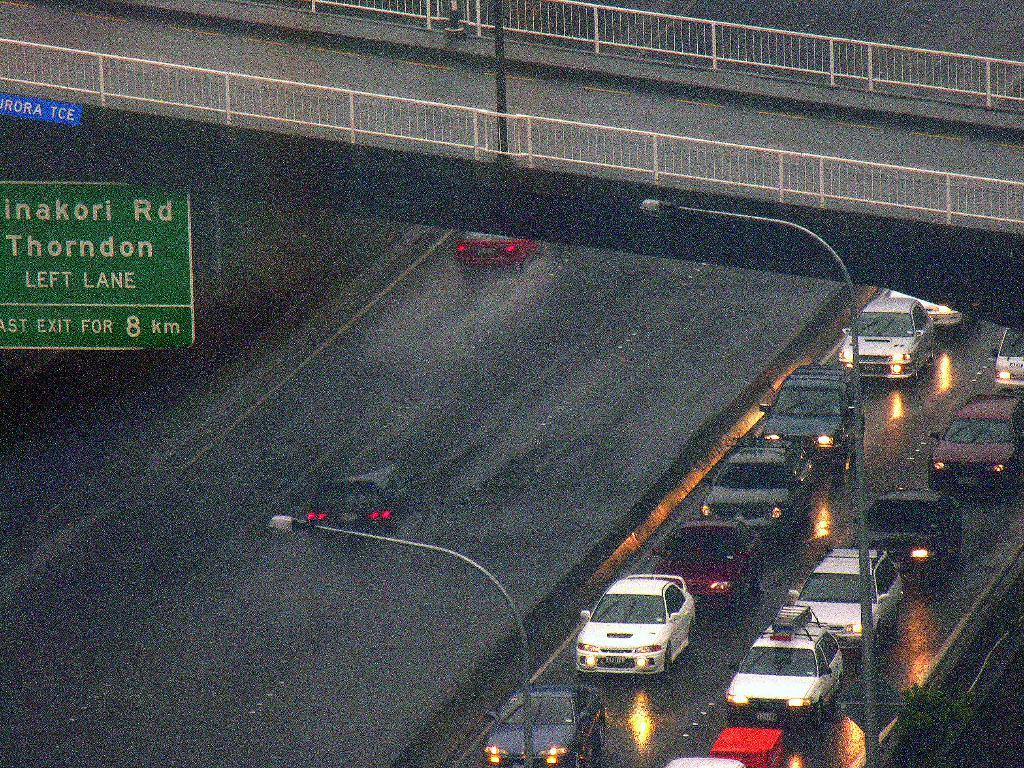What types of objects are present in the image? There are vehicles and light poles in the image. What colors can be seen on the boards in the image? The boards in the image are in green and blue colors. What can be seen in the background of the image? The background of the image includes railing. What type of picture is the minister holding in the image? There is no minister or picture present in the image. Is there a bear visible in the image? No, there is no bear present in the image. 